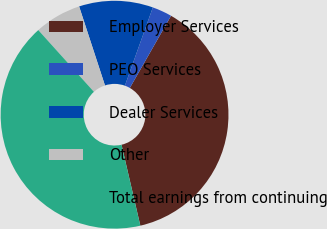<chart> <loc_0><loc_0><loc_500><loc_500><pie_chart><fcel>Employer Services<fcel>PEO Services<fcel>Dealer Services<fcel>Other<fcel>Total earnings from continuing<nl><fcel>38.11%<fcel>2.8%<fcel>10.49%<fcel>6.64%<fcel>41.96%<nl></chart> 